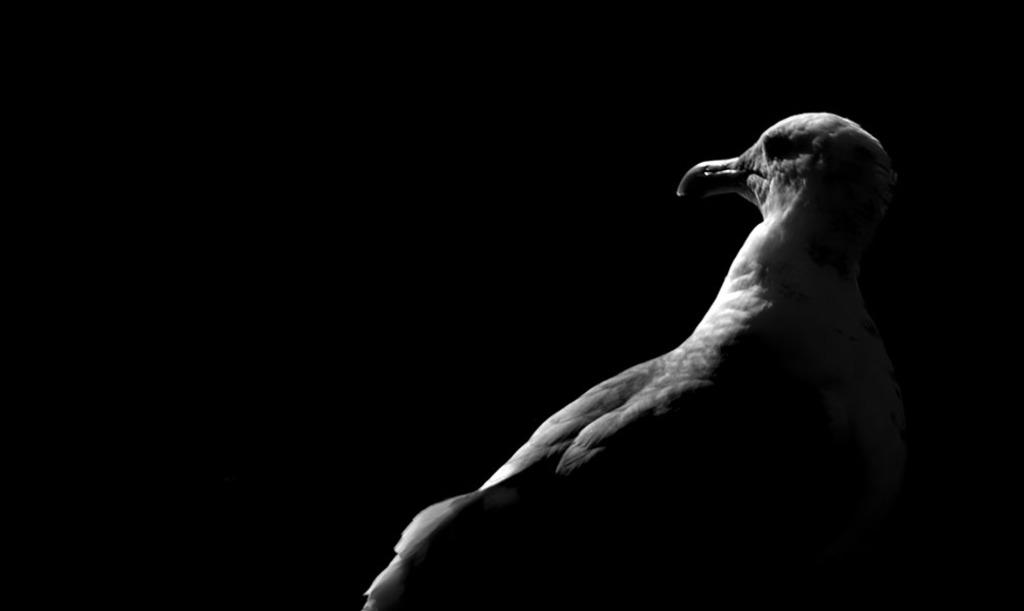What type of animal can be seen in the image? There is a bird in the image. What can be observed about the background of the image? The background of the image is dark. What type of footwear is the bird wearing in the image? There is no footwear present in the image, as birds do not wear shoes. 